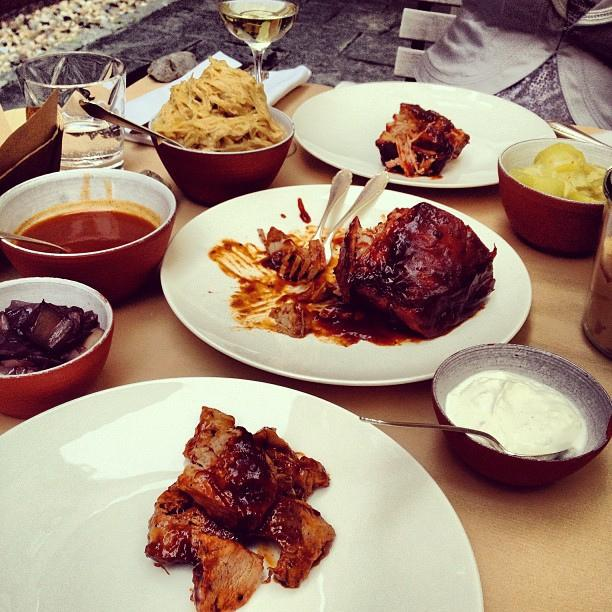What type feast is being served here? Please explain your reasoning. barbeque. As indicated by the grilled parts of meat and many sauces. the foods necessary for the other options aren't in the image. 